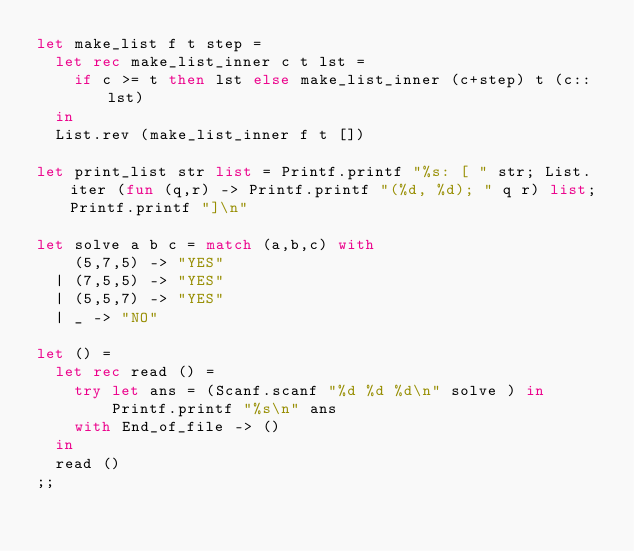Convert code to text. <code><loc_0><loc_0><loc_500><loc_500><_OCaml_>let make_list f t step =
  let rec make_list_inner c t lst =
    if c >= t then lst else make_list_inner (c+step) t (c::lst)
  in
  List.rev (make_list_inner f t [])

let print_list str list = Printf.printf "%s: [ " str; List.iter (fun (q,r) -> Printf.printf "(%d, %d); " q r) list; Printf.printf "]\n"

let solve a b c = match (a,b,c) with
    (5,7,5) -> "YES"
  | (7,5,5) -> "YES"
  | (5,5,7) -> "YES"
  | _ -> "NO"

let () =
  let rec read () =
    try let ans = (Scanf.scanf "%d %d %d\n" solve ) in
        Printf.printf "%s\n" ans
    with End_of_file -> ()
  in
  read ()
;;
</code> 